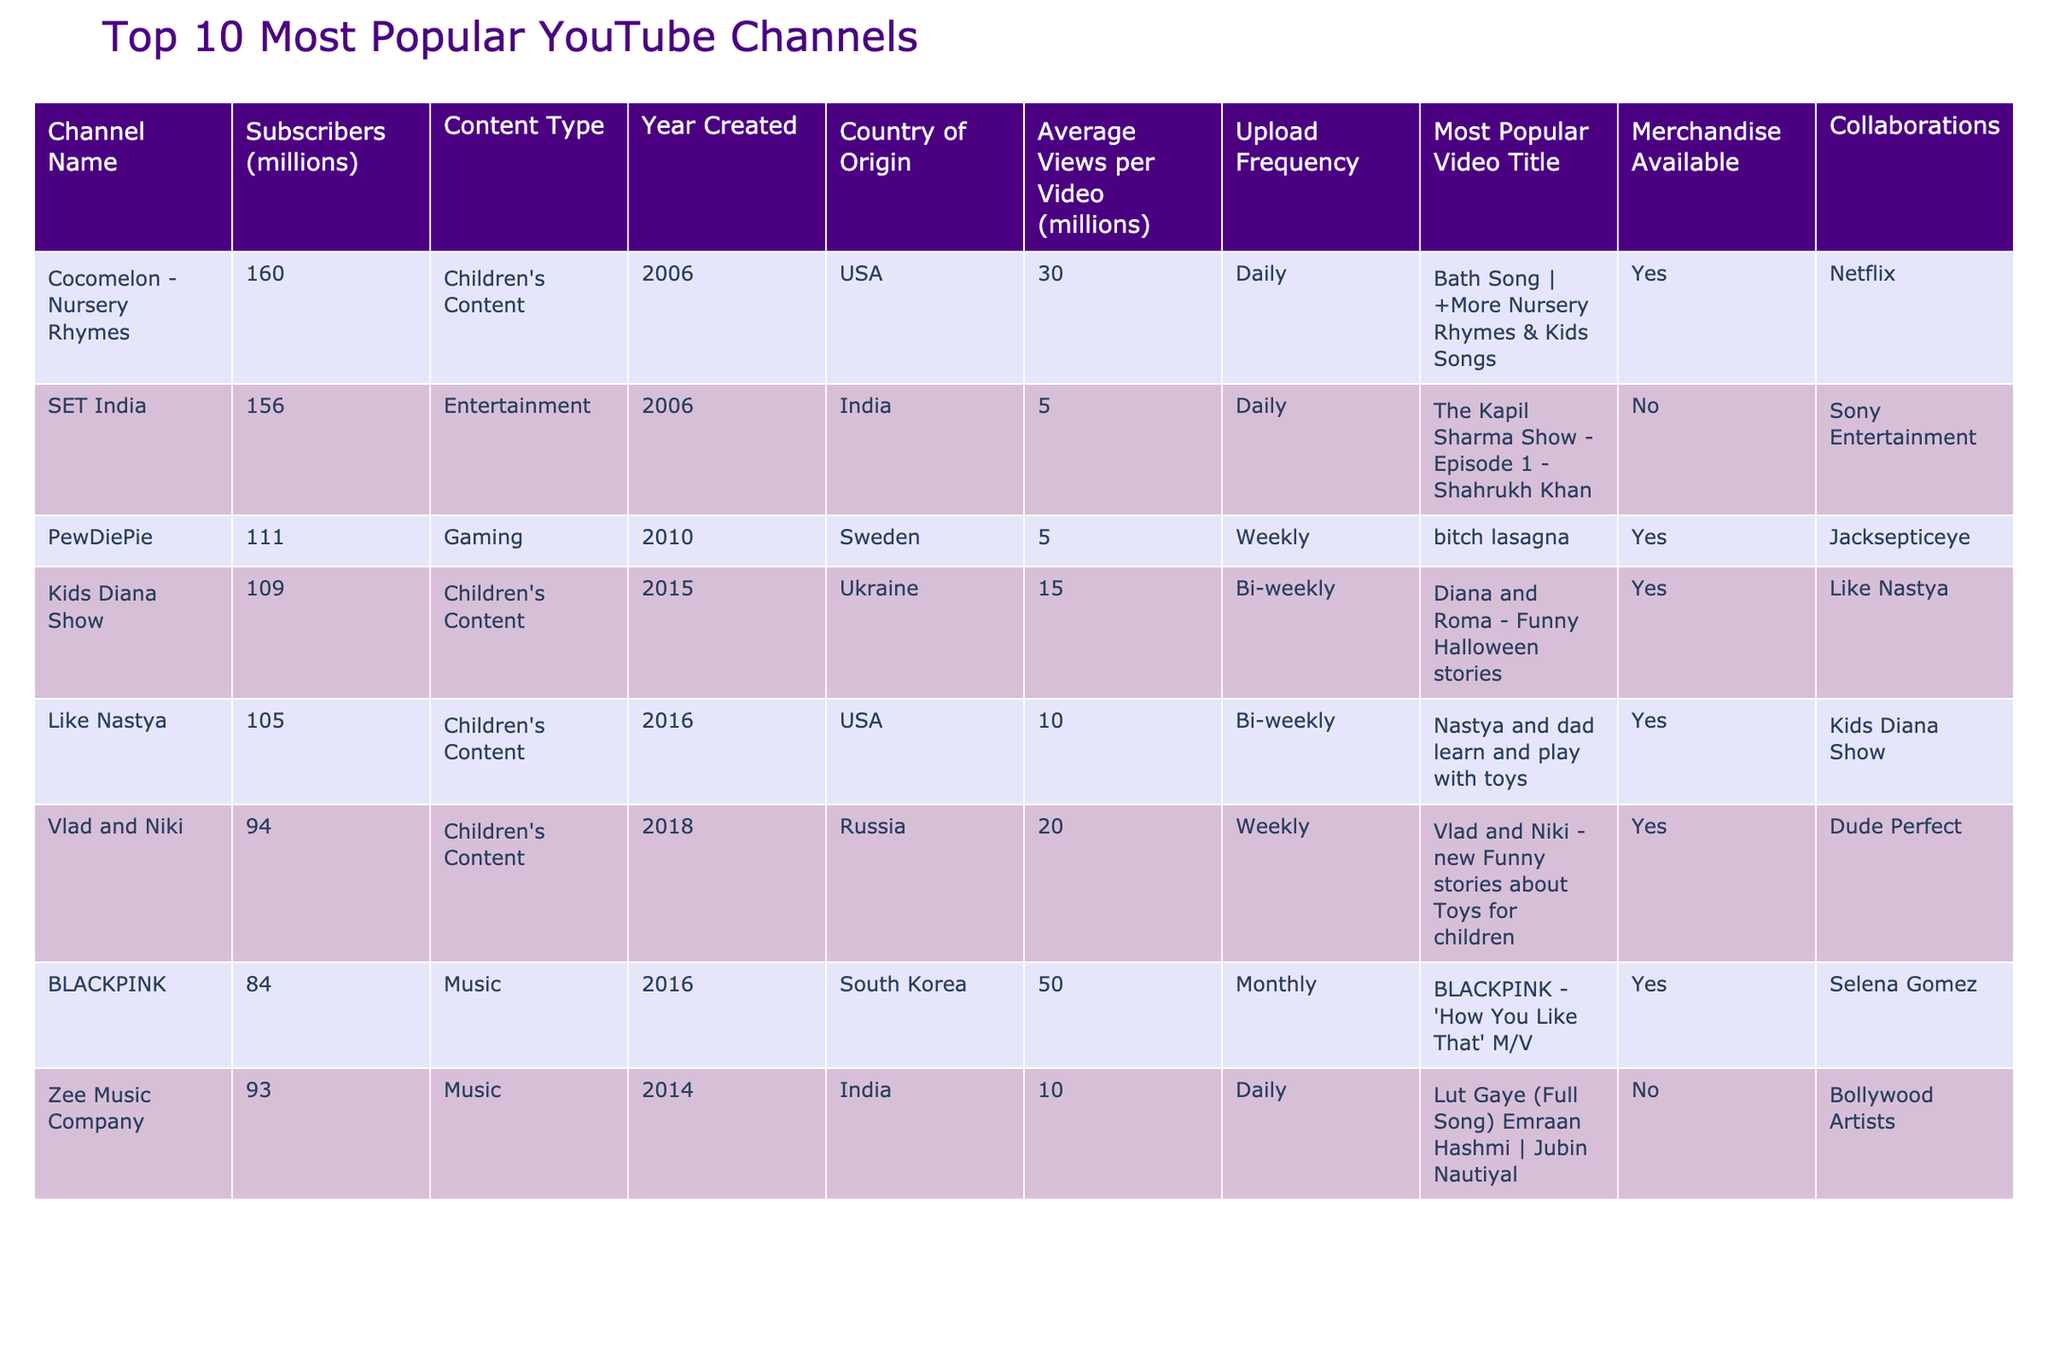What is the name of the channel with the most subscribers? Looking at the Subscribers column in the table, Cocomelon - Nursery Rhymes has the highest subscriber count with 160 million.
Answer: Cocomelon - Nursery Rhymes Which channel was created in 2016? From the Year Created column, Like Nastya was created in 2016.
Answer: Like Nastya What type of content does Vlad and Niki focus on? By referring to the Content Type column, Vlad and Niki produces Children's Content.
Answer: Children's Content What is the average number of subscribers for the top three channels? The top three channels have subscriber counts of 160, 156, and 111 million. The sum is 160 + 156 + 111 = 427. To find the average, divide by 3: 427 / 3 ≈ 142.33 million.
Answer: 142.33 million Does the Kids Diana Show have merchandise available? Checking the Merchandise Available column for Kids Diana Show indicates that it has merchandise available (Yes).
Answer: Yes Which channel has the highest average views per video? Looking through the Average Views per Video column, BLACKPINK has the highest average views per video at 50 million.
Answer: BLACKPINK Is there any channel from Ukraine in the list? According to the Country of Origin column, Kids Diana Show is from Ukraine and appears in the list.
Answer: Yes How many channels have a daily upload frequency? Observing the Upload Frequency column, both Cocomelon - Nursery Rhymes and Zee Music Company have a daily upload frequency, totaling two channels.
Answer: 2 Which country has the most channels on the list? The USA appears twice with Cocomelon - Nursery Rhymes and Like Nastya, while India also appears twice with SET India and Zee Music Company, making it a tie.
Answer: Tie between USA and India Which channel's most popular video is titled "Diana and Roma - Funny Halloween stories"? By examining the Most Popular Video Title column, this title belongs to Kids Diana Show.
Answer: Kids Diana Show What is the difference in subscriber count between PewDiePie and BLACKPINK? PewDiePie has 111 million subscribers, and BLACKPINK has 84 million. The difference is 111 - 84 = 27 million.
Answer: 27 million 